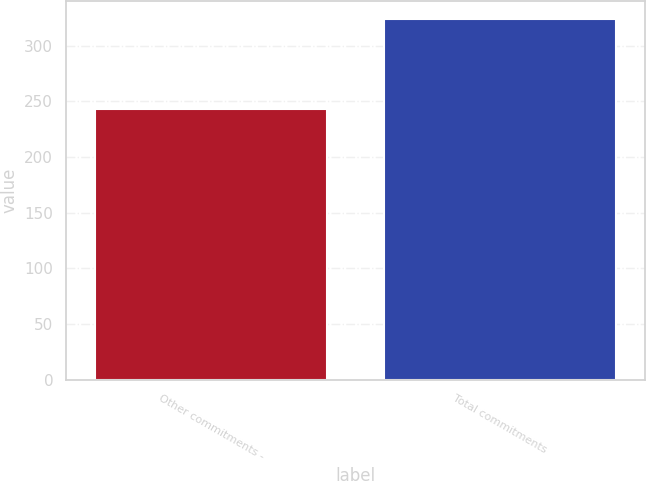Convert chart to OTSL. <chart><loc_0><loc_0><loc_500><loc_500><bar_chart><fcel>Other commitments -<fcel>Total commitments<nl><fcel>243<fcel>324<nl></chart> 